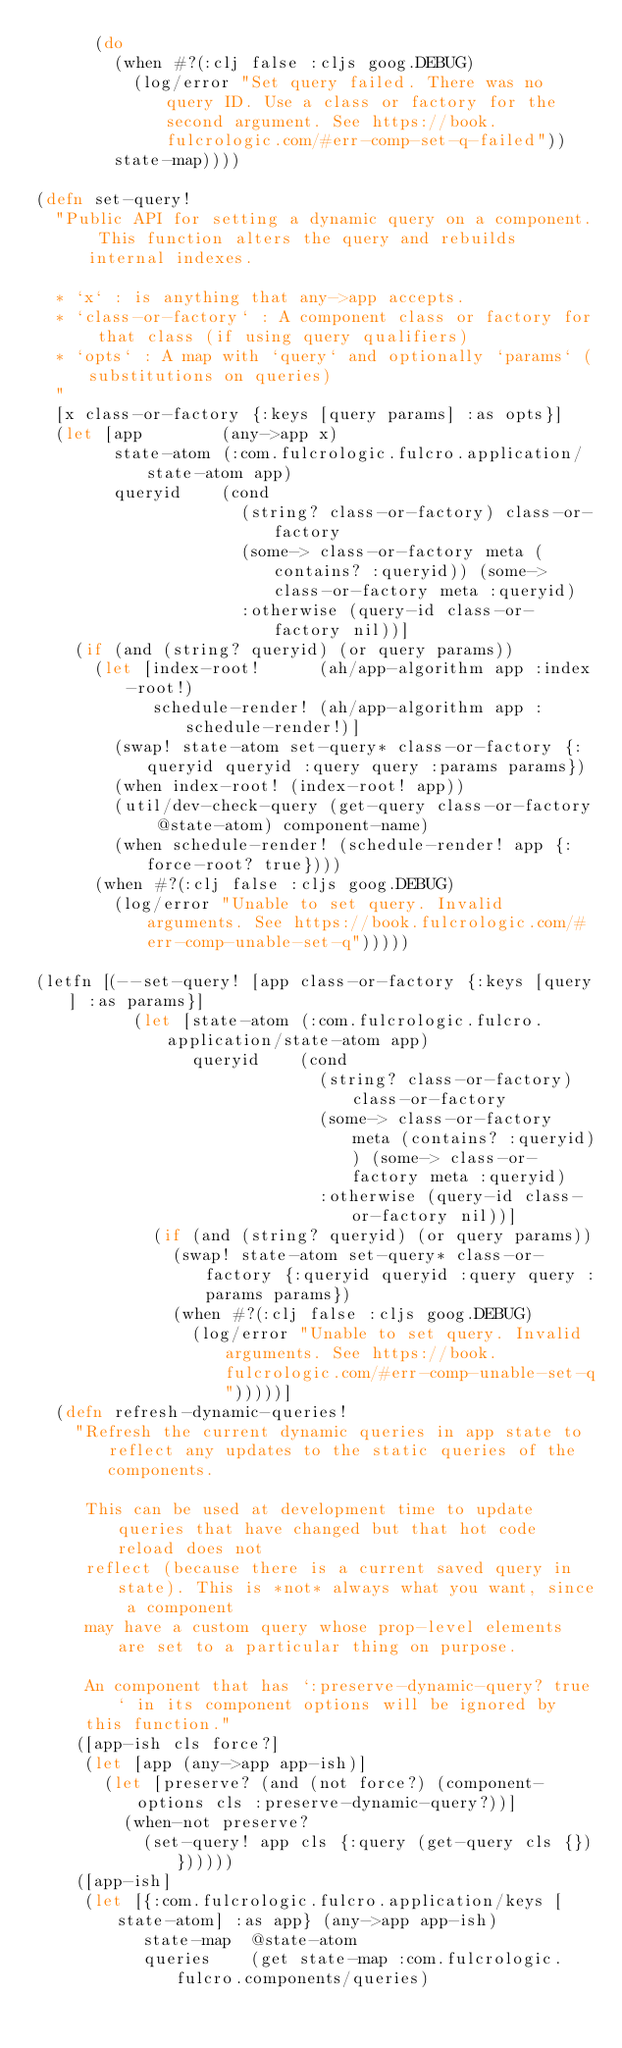Convert code to text. <code><loc_0><loc_0><loc_500><loc_500><_Clojure_>      (do
        (when #?(:clj false :cljs goog.DEBUG)
          (log/error "Set query failed. There was no query ID. Use a class or factory for the second argument. See https://book.fulcrologic.com/#err-comp-set-q-failed"))
        state-map))))

(defn set-query!
  "Public API for setting a dynamic query on a component. This function alters the query and rebuilds internal indexes.

  * `x` : is anything that any->app accepts.
  * `class-or-factory` : A component class or factory for that class (if using query qualifiers)
  * `opts` : A map with `query` and optionally `params` (substitutions on queries)
  "
  [x class-or-factory {:keys [query params] :as opts}]
  (let [app        (any->app x)
        state-atom (:com.fulcrologic.fulcro.application/state-atom app)
        queryid    (cond
                     (string? class-or-factory) class-or-factory
                     (some-> class-or-factory meta (contains? :queryid)) (some-> class-or-factory meta :queryid)
                     :otherwise (query-id class-or-factory nil))]
    (if (and (string? queryid) (or query params))
      (let [index-root!      (ah/app-algorithm app :index-root!)
            schedule-render! (ah/app-algorithm app :schedule-render!)]
        (swap! state-atom set-query* class-or-factory {:queryid queryid :query query :params params})
        (when index-root! (index-root! app))
        (util/dev-check-query (get-query class-or-factory @state-atom) component-name)
        (when schedule-render! (schedule-render! app {:force-root? true})))
      (when #?(:clj false :cljs goog.DEBUG)
        (log/error "Unable to set query. Invalid arguments. See https://book.fulcrologic.com/#err-comp-unable-set-q")))))

(letfn [(--set-query! [app class-or-factory {:keys [query] :as params}]
          (let [state-atom (:com.fulcrologic.fulcro.application/state-atom app)
                queryid    (cond
                             (string? class-or-factory) class-or-factory
                             (some-> class-or-factory meta (contains? :queryid)) (some-> class-or-factory meta :queryid)
                             :otherwise (query-id class-or-factory nil))]
            (if (and (string? queryid) (or query params))
              (swap! state-atom set-query* class-or-factory {:queryid queryid :query query :params params})
              (when #?(:clj false :cljs goog.DEBUG)
                (log/error "Unable to set query. Invalid arguments. See https://book.fulcrologic.com/#err-comp-unable-set-q")))))]
  (defn refresh-dynamic-queries!
    "Refresh the current dynamic queries in app state to reflect any updates to the static queries of the components.

     This can be used at development time to update queries that have changed but that hot code reload does not
     reflect (because there is a current saved query in state). This is *not* always what you want, since a component
     may have a custom query whose prop-level elements are set to a particular thing on purpose.

     An component that has `:preserve-dynamic-query? true` in its component options will be ignored by
     this function."
    ([app-ish cls force?]
     (let [app (any->app app-ish)]
       (let [preserve? (and (not force?) (component-options cls :preserve-dynamic-query?))]
         (when-not preserve?
           (set-query! app cls {:query (get-query cls {})})))))
    ([app-ish]
     (let [{:com.fulcrologic.fulcro.application/keys [state-atom] :as app} (any->app app-ish)
           state-map  @state-atom
           queries    (get state-map :com.fulcrologic.fulcro.components/queries)</code> 